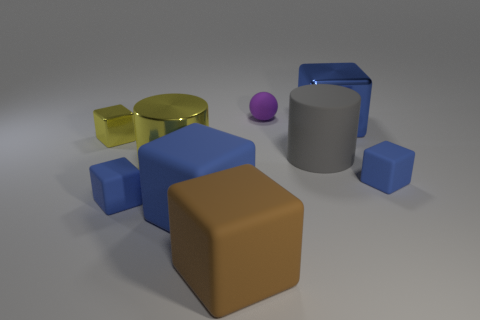Subtract all blue balls. How many blue cubes are left? 4 Subtract all big metal cubes. How many cubes are left? 5 Subtract all brown blocks. How many blocks are left? 5 Subtract all yellow blocks. Subtract all cyan spheres. How many blocks are left? 5 Subtract all cylinders. How many objects are left? 7 Add 6 tiny metallic objects. How many tiny metallic objects exist? 7 Subtract 0 green cylinders. How many objects are left? 9 Subtract all yellow rubber cubes. Subtract all big metal blocks. How many objects are left? 8 Add 5 big matte cylinders. How many big matte cylinders are left? 6 